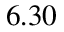<formula> <loc_0><loc_0><loc_500><loc_500>6 . 3 0</formula> 